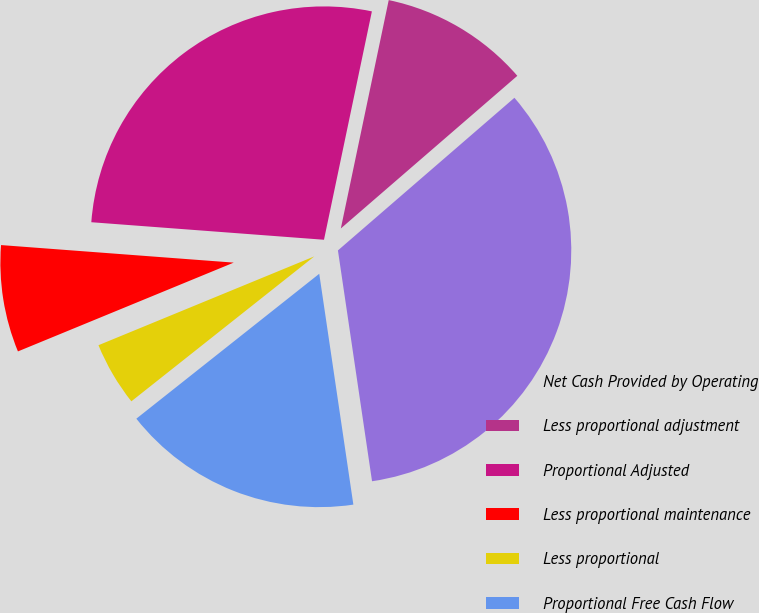Convert chart to OTSL. <chart><loc_0><loc_0><loc_500><loc_500><pie_chart><fcel>Net Cash Provided by Operating<fcel>Less proportional adjustment<fcel>Proportional Adjusted<fcel>Less proportional maintenance<fcel>Less proportional<fcel>Proportional Free Cash Flow<nl><fcel>34.01%<fcel>10.36%<fcel>27.09%<fcel>7.41%<fcel>4.45%<fcel>16.67%<nl></chart> 